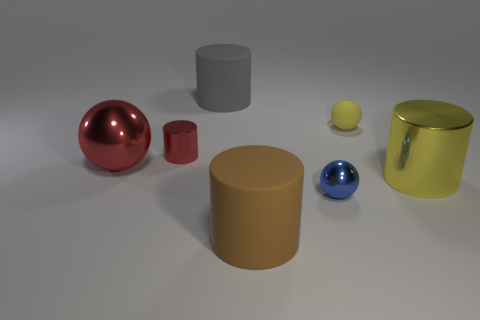Add 2 large objects. How many objects exist? 9 Subtract all yellow cylinders. How many cylinders are left? 3 Subtract all small spheres. How many spheres are left? 1 Subtract 1 balls. How many balls are left? 2 Subtract all cylinders. How many objects are left? 3 Subtract all purple spheres. Subtract all yellow blocks. How many spheres are left? 3 Add 2 brown matte cylinders. How many brown matte cylinders are left? 3 Add 7 big matte things. How many big matte things exist? 9 Subtract 0 purple balls. How many objects are left? 7 Subtract all blue things. Subtract all large rubber cylinders. How many objects are left? 4 